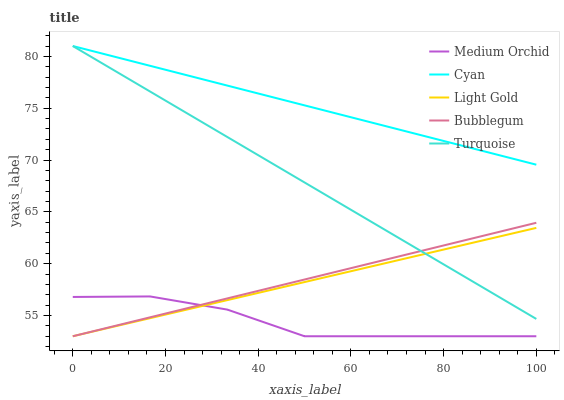Does Medium Orchid have the minimum area under the curve?
Answer yes or no. Yes. Does Cyan have the maximum area under the curve?
Answer yes or no. Yes. Does Turquoise have the minimum area under the curve?
Answer yes or no. No. Does Turquoise have the maximum area under the curve?
Answer yes or no. No. Is Light Gold the smoothest?
Answer yes or no. Yes. Is Medium Orchid the roughest?
Answer yes or no. Yes. Is Turquoise the smoothest?
Answer yes or no. No. Is Turquoise the roughest?
Answer yes or no. No. Does Medium Orchid have the lowest value?
Answer yes or no. Yes. Does Turquoise have the lowest value?
Answer yes or no. No. Does Turquoise have the highest value?
Answer yes or no. Yes. Does Medium Orchid have the highest value?
Answer yes or no. No. Is Medium Orchid less than Turquoise?
Answer yes or no. Yes. Is Cyan greater than Light Gold?
Answer yes or no. Yes. Does Bubblegum intersect Light Gold?
Answer yes or no. Yes. Is Bubblegum less than Light Gold?
Answer yes or no. No. Is Bubblegum greater than Light Gold?
Answer yes or no. No. Does Medium Orchid intersect Turquoise?
Answer yes or no. No. 